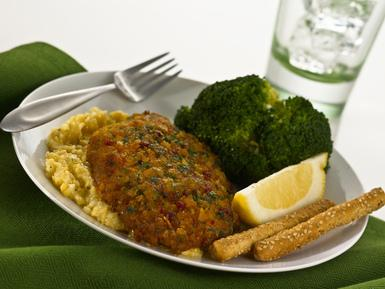Which item on the plate likely is highest in vitamins and minerals? Please explain your reasoning. broccoli. Broccoli is good for you 